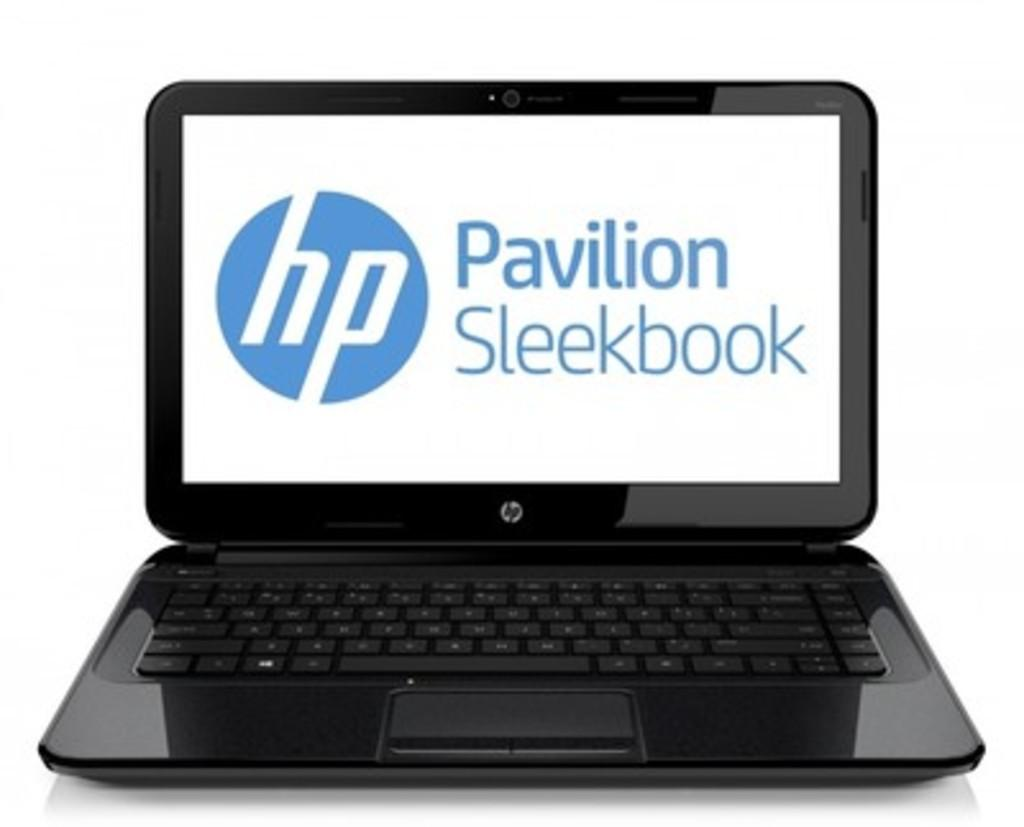<image>
Present a compact description of the photo's key features. A HP laptop with a screen that says Pavilion Sleekbook. 